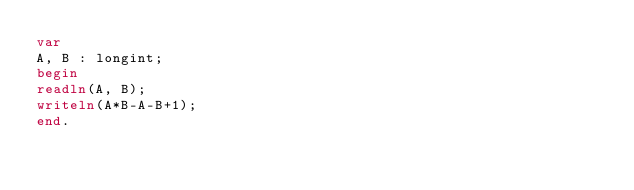Convert code to text. <code><loc_0><loc_0><loc_500><loc_500><_Pascal_>var
A, B : longint;
begin
readln(A, B);
writeln(A*B-A-B+1);
end.</code> 